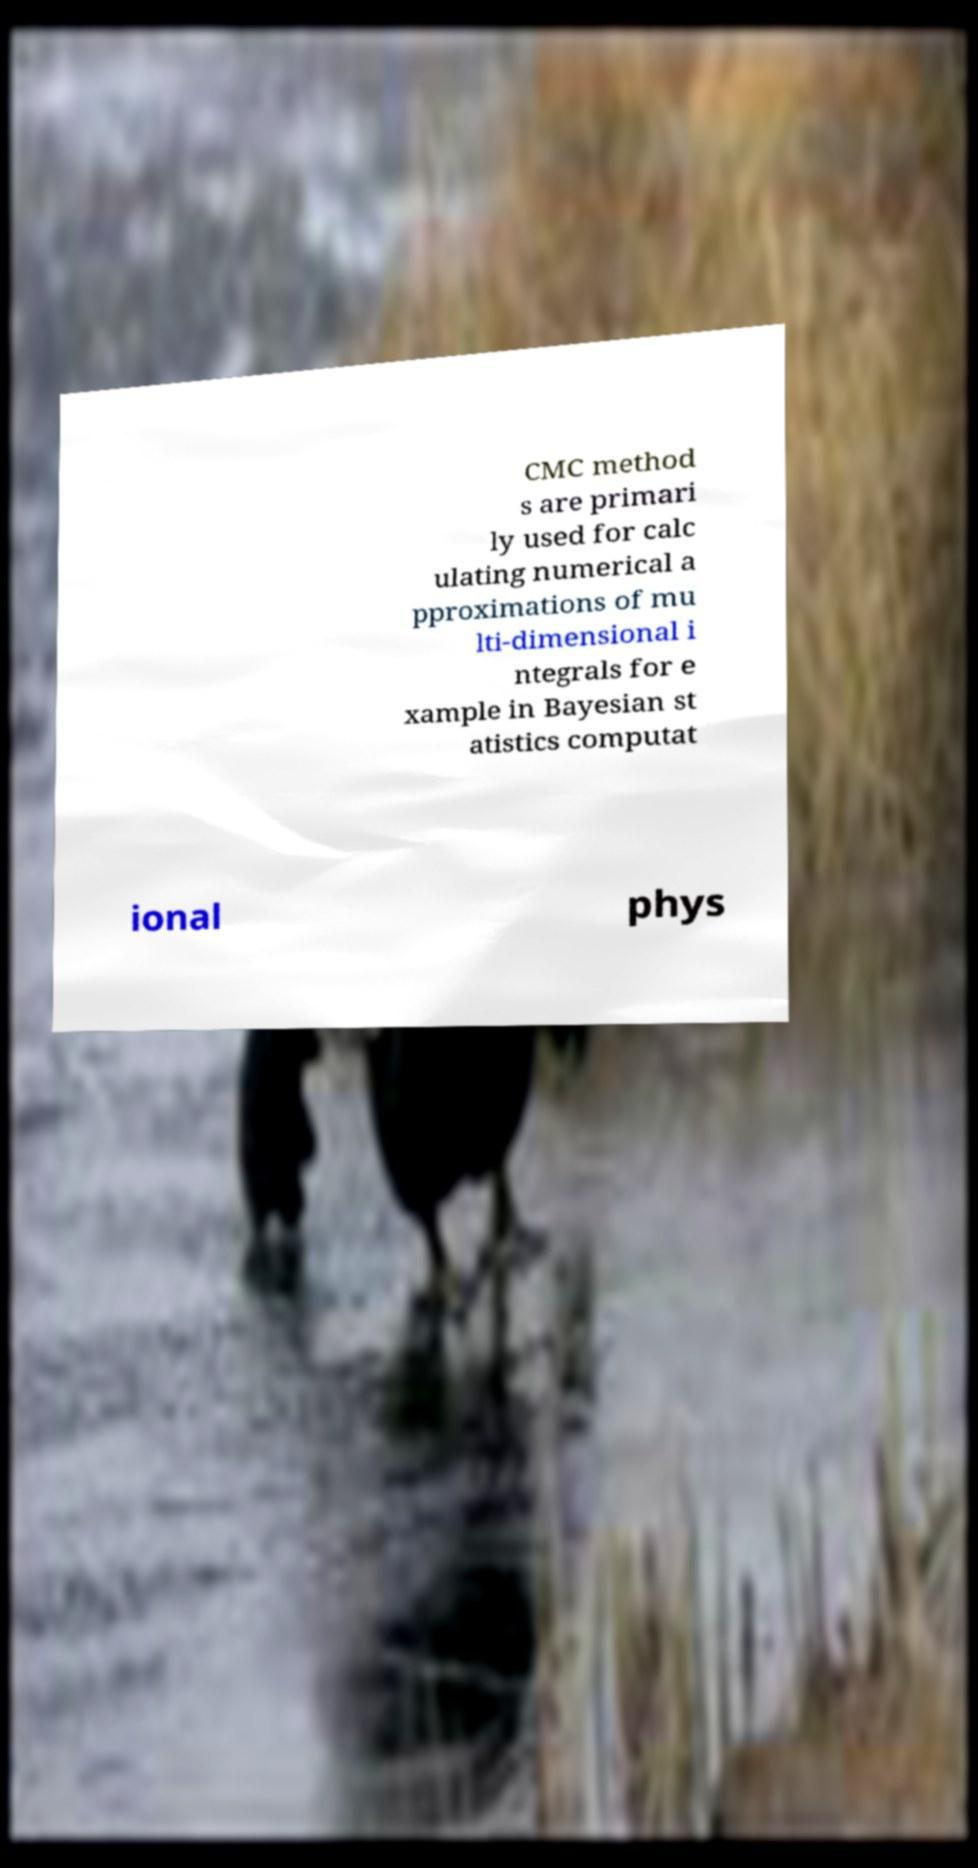There's text embedded in this image that I need extracted. Can you transcribe it verbatim? CMC method s are primari ly used for calc ulating numerical a pproximations of mu lti-dimensional i ntegrals for e xample in Bayesian st atistics computat ional phys 